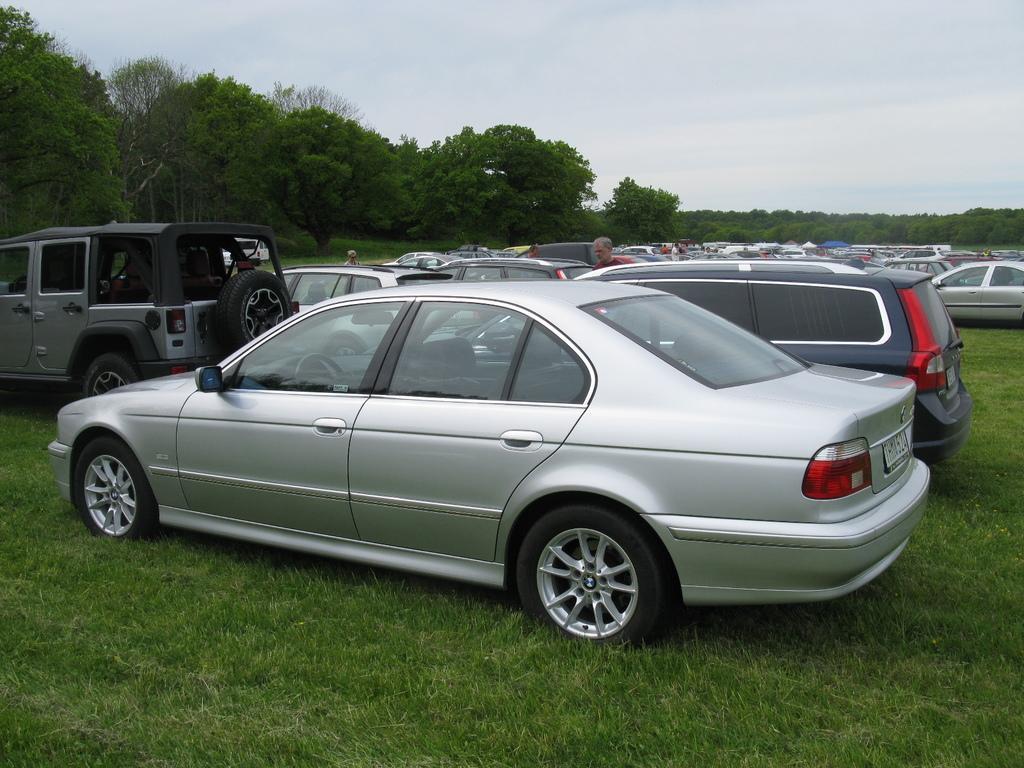Can you describe this image briefly? There are different types of cars, which are parked. Here is a grass. I can see a person standing. These are the trees with branches and leaves. This is the sky. 